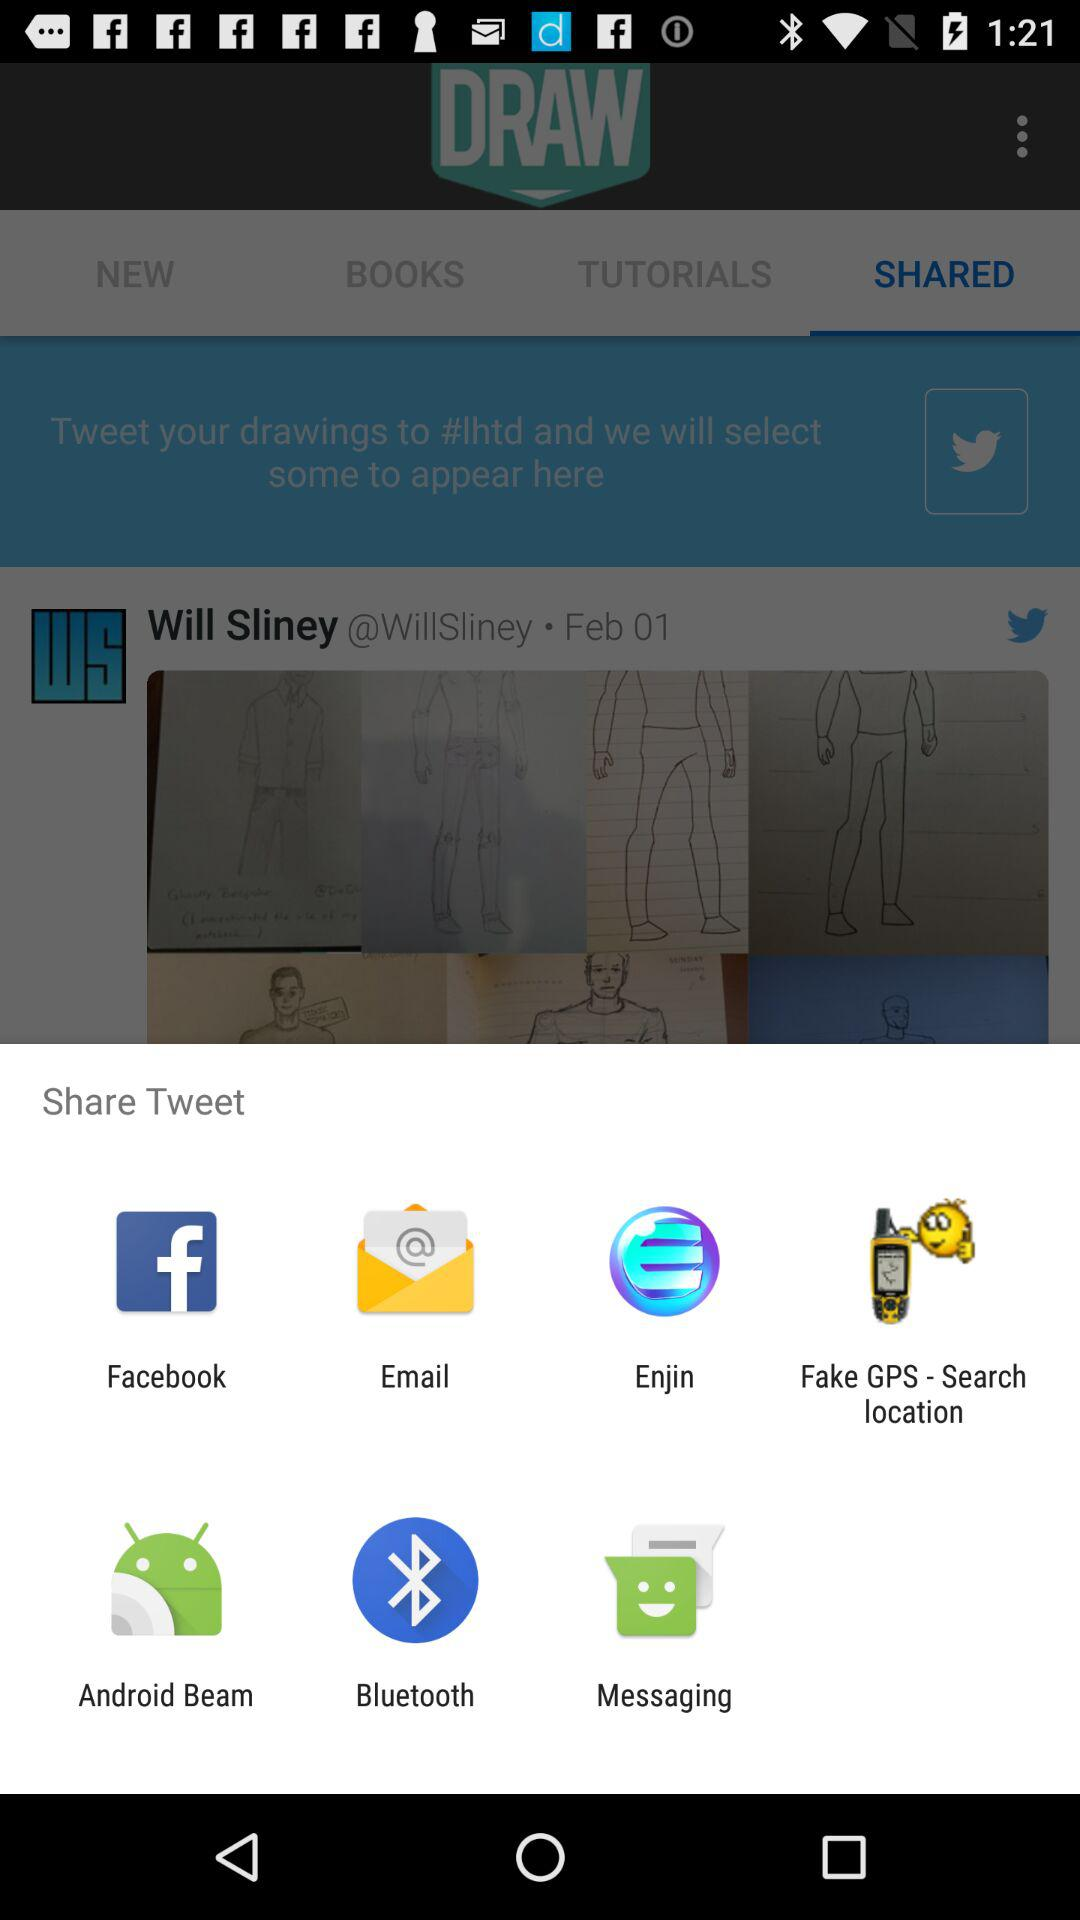What are the options to share? The options to share are "Facebook", "Email", "Enjin", "Fake GPS - Search location", "Android Beam", "Bluetooth" and "Messaging". 